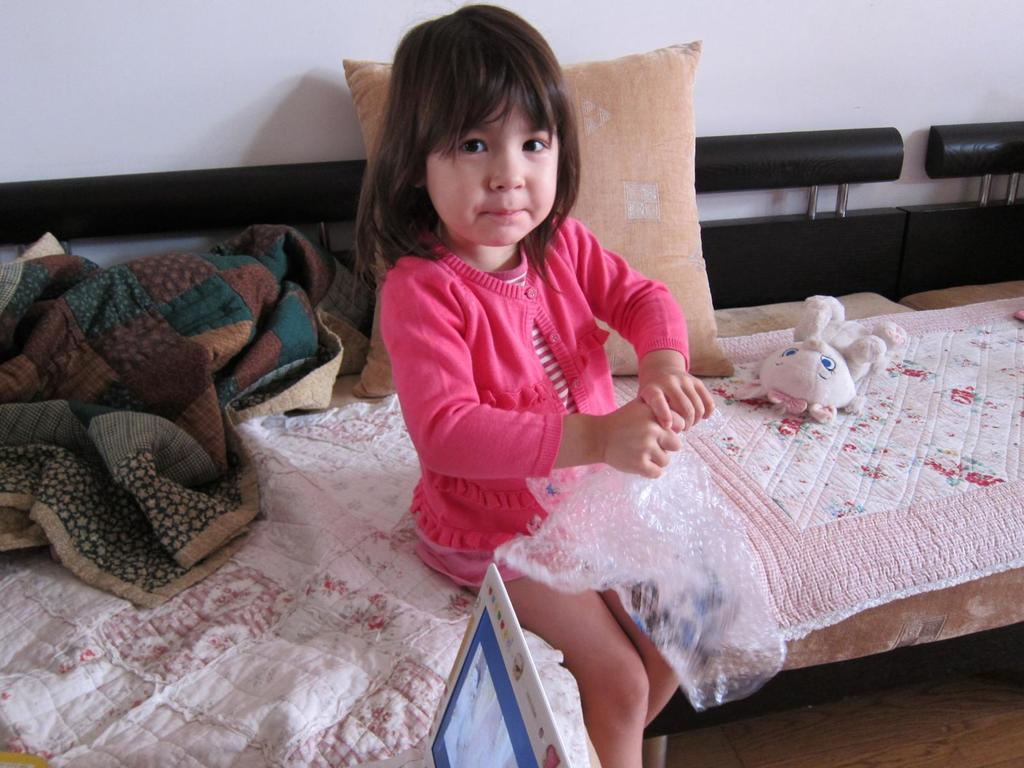Who is the main subject in the image? There is a baby girl in the image. Where is the baby girl sitting? The baby girl is sitting on a sofa. What items are present in the image that might be used for comfort or warmth? There is a blanket and a pillow in the image. What toy can be seen in the image? There is a doll in the image. What type of mark does the baby girl have on her forehead in the image? There is no mark visible on the baby girl's forehead in the image. 